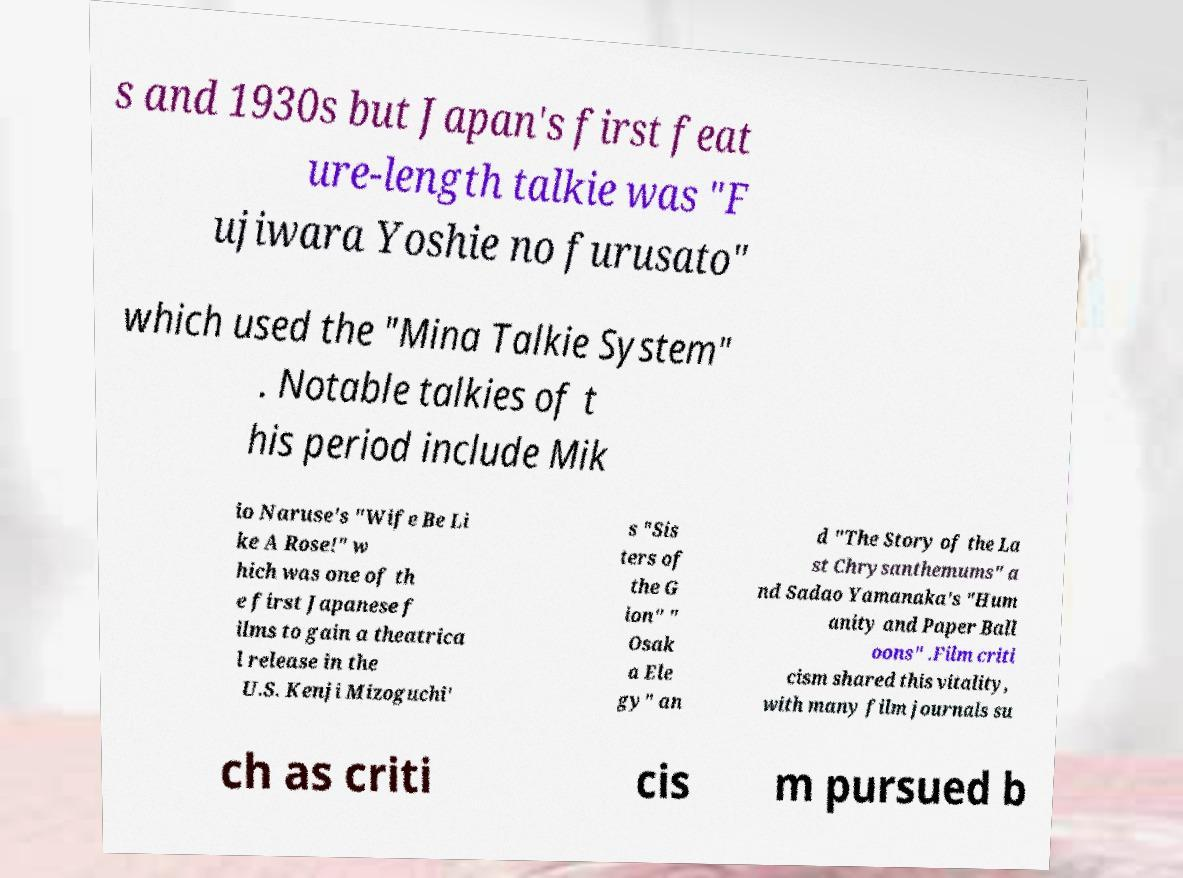Can you accurately transcribe the text from the provided image for me? s and 1930s but Japan's first feat ure-length talkie was "F ujiwara Yoshie no furusato" which used the "Mina Talkie System" . Notable talkies of t his period include Mik io Naruse's "Wife Be Li ke A Rose!" w hich was one of th e first Japanese f ilms to gain a theatrica l release in the U.S. Kenji Mizoguchi' s "Sis ters of the G ion" " Osak a Ele gy" an d "The Story of the La st Chrysanthemums" a nd Sadao Yamanaka's "Hum anity and Paper Ball oons" .Film criti cism shared this vitality, with many film journals su ch as criti cis m pursued b 